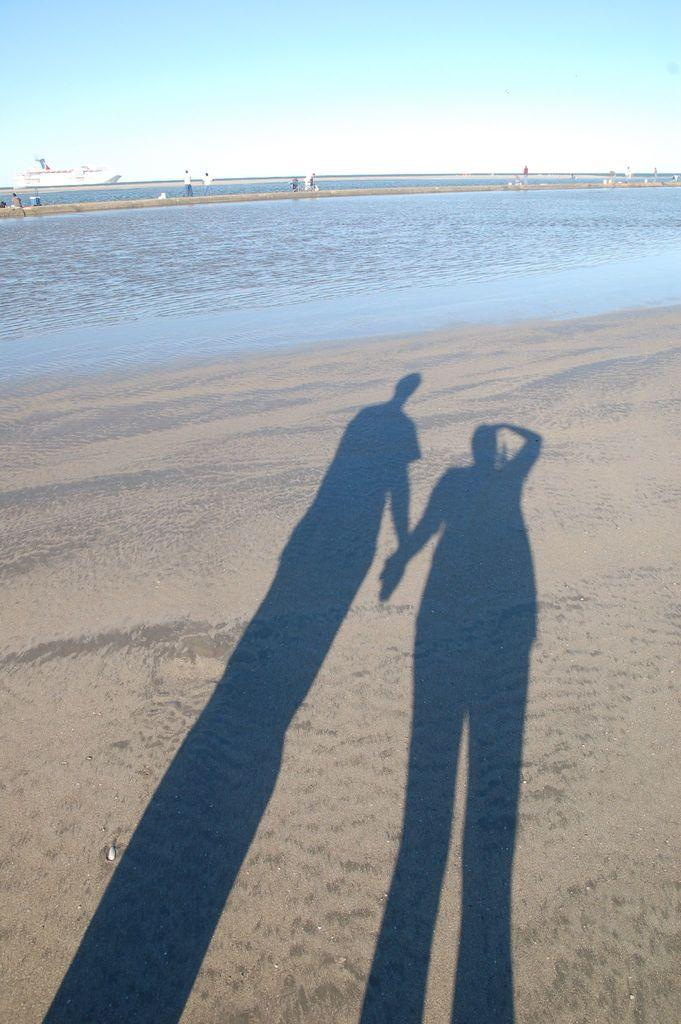What can be seen in the background of the image? There is a ship visible in the background of the image. How many people are depicted in the image? There are people standing in the image. What type of setting is shown in the image? The image depicts a sea setting. Can you describe the shadows in the image? There are shadows of two people in the image. What type of voice can be heard coming from the ship in the image? There is no indication of any sound or voice in the image, as it is a still photograph. What order are the people standing in the image? The image does not depict a specific order in which the people are standing; they are simply standing. 